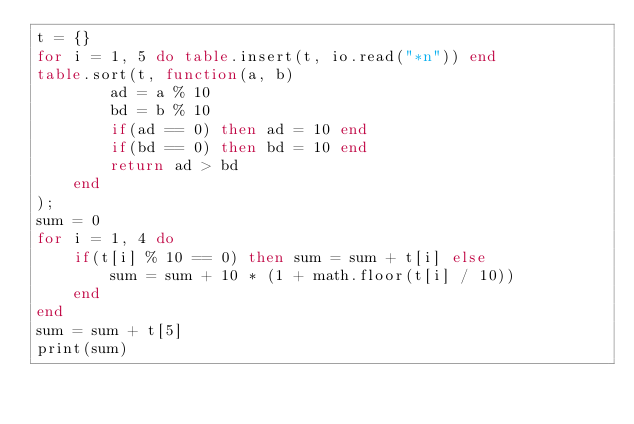<code> <loc_0><loc_0><loc_500><loc_500><_Lua_>t = {}
for i = 1, 5 do table.insert(t, io.read("*n")) end
table.sort(t, function(a, b)
        ad = a % 10
        bd = b % 10
        if(ad == 0) then ad = 10 end
        if(bd == 0) then bd = 10 end
        return ad > bd
    end
);
sum = 0
for i = 1, 4 do
    if(t[i] % 10 == 0) then sum = sum + t[i] else
        sum = sum + 10 * (1 + math.floor(t[i] / 10))
    end
end
sum = sum + t[5]
print(sum)</code> 